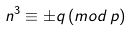Convert formula to latex. <formula><loc_0><loc_0><loc_500><loc_500>n ^ { 3 } \equiv \pm q \, ( m o d \, p )</formula> 